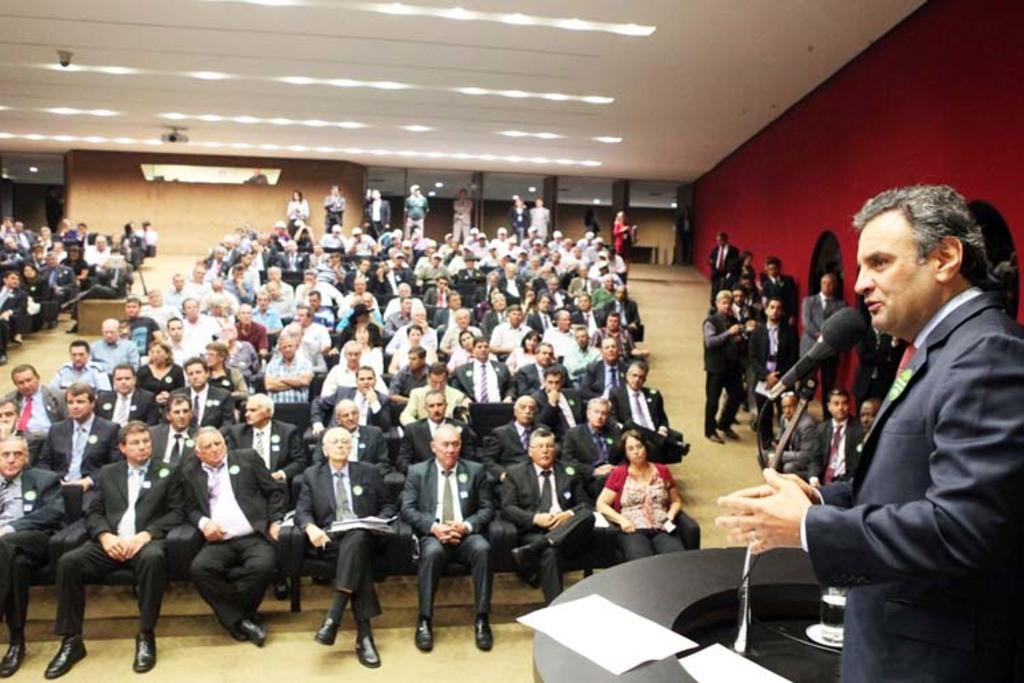Could you give a brief overview of what you see in this image? In this image I can see group of people, some are sitting and some are standing and I can see the person standing in front of the podium and I can also see the microphone. In the background I can see few lights and the projector. 